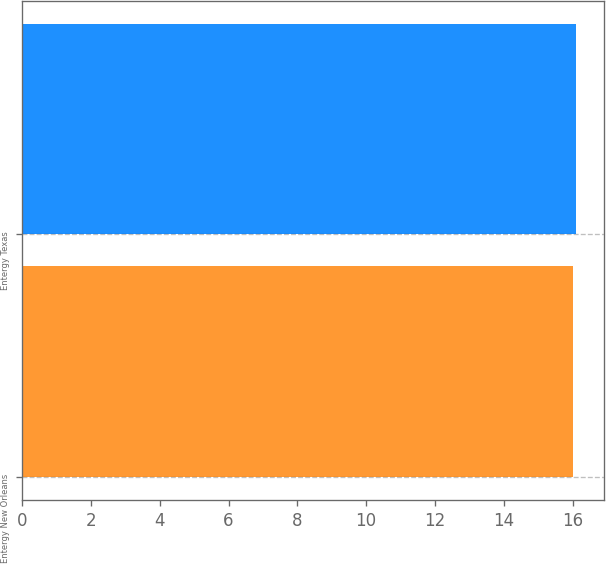Convert chart. <chart><loc_0><loc_0><loc_500><loc_500><bar_chart><fcel>Entergy New Orleans<fcel>Entergy Texas<nl><fcel>16<fcel>16.1<nl></chart> 